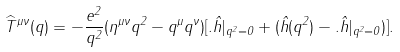Convert formula to latex. <formula><loc_0><loc_0><loc_500><loc_500>\widehat { T } ^ { \mu \nu } ( q ) = - \frac { e ^ { 2 } } { q ^ { 2 } } ( \eta ^ { \mu \nu } q ^ { 2 } - q ^ { \mu } q ^ { \nu } ) [ . \hat { h } | _ { q ^ { 2 } = 0 } + ( \hat { h } ( q ^ { 2 } ) - . \hat { h } | _ { q ^ { 2 } = 0 } ) ] .</formula> 